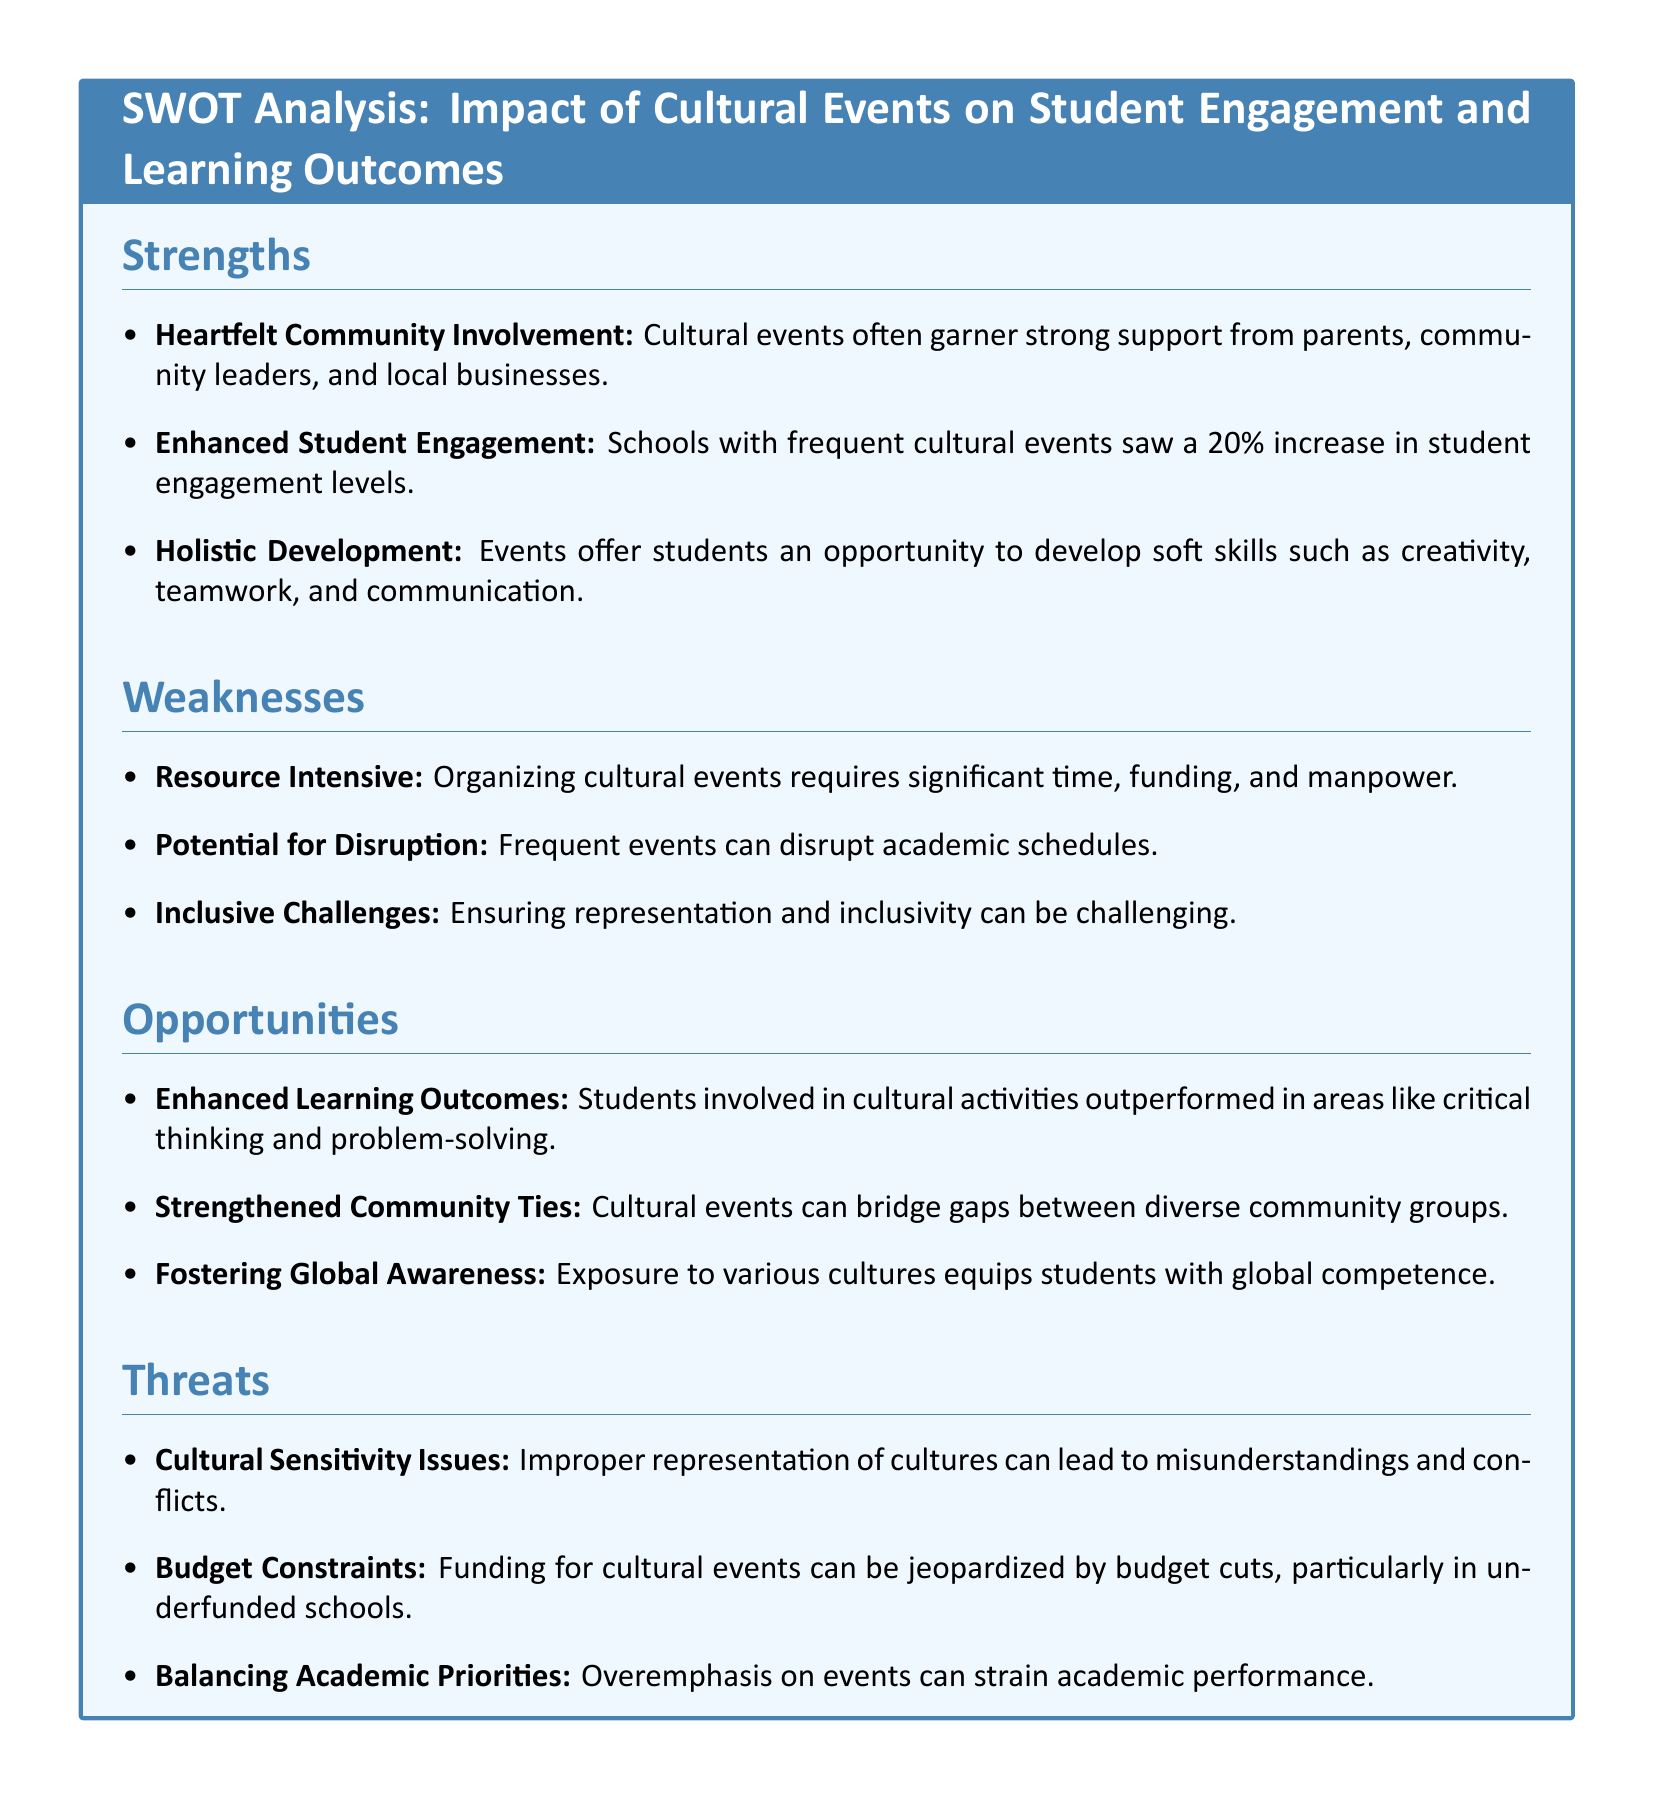What is the percentage increase in student engagement levels? The document states that schools with frequent cultural events saw a 20% increase in student engagement levels.
Answer: 20% What is one of the soft skills developed through cultural events? The document lists creativity, teamwork, and communication as soft skills developed through cultural events.
Answer: Creativity What is a major weakness related to organizing cultural events? Organizing cultural events requires significant time, funding, and manpower, which are defined as weaknesses in the document.
Answer: Resource Intensive What is one opportunity mentioned for enhancing student performance? The document states that students involved in cultural activities outperformed in areas like critical thinking and problem-solving, indicating an opportunity for enhanced learning outcomes.
Answer: Enhanced Learning Outcomes What can cultural events help to strengthen within the community? The document mentions that cultural events can bridge gaps between diverse community groups, indicating strengthened community ties.
Answer: Strengthened Community Ties What is a potential threat related to budget? The document references that funding for cultural events can be jeopardized by budget cuts, especially in underfunded schools, indicating a threat.
Answer: Budget Constraints What aspect of cultural events can lead to misunderstandings? The document identifies improper representation of cultures as a cause for misunderstandings and conflicts associated with cultural events.
Answer: Cultural Sensitivity Issues What is the primary document type being analyzed? The document is a SWOT analysis, which stands for Strengths, Weaknesses, Opportunities, and Threats.
Answer: SWOT analysis What does the term "inclusive challenges" refer to in the document? It refers to the difficulty in ensuring representation and inclusivity during cultural events, as stated under weaknesses.
Answer: Inclusive Challenges 